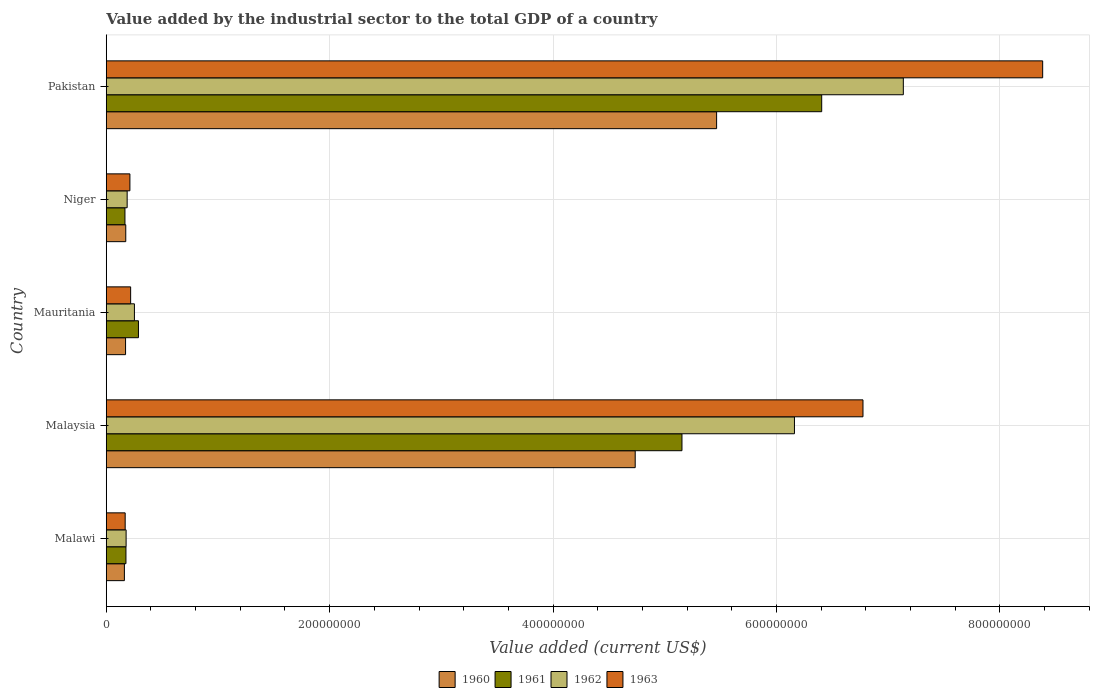Are the number of bars on each tick of the Y-axis equal?
Your answer should be very brief. Yes. How many bars are there on the 3rd tick from the top?
Provide a succinct answer. 4. How many bars are there on the 4th tick from the bottom?
Provide a succinct answer. 4. What is the label of the 3rd group of bars from the top?
Offer a very short reply. Mauritania. What is the value added by the industrial sector to the total GDP in 1961 in Malawi?
Offer a very short reply. 1.76e+07. Across all countries, what is the maximum value added by the industrial sector to the total GDP in 1960?
Ensure brevity in your answer.  5.46e+08. Across all countries, what is the minimum value added by the industrial sector to the total GDP in 1962?
Your response must be concise. 1.78e+07. In which country was the value added by the industrial sector to the total GDP in 1962 minimum?
Ensure brevity in your answer.  Malawi. What is the total value added by the industrial sector to the total GDP in 1963 in the graph?
Offer a terse response. 1.58e+09. What is the difference between the value added by the industrial sector to the total GDP in 1962 in Malaysia and that in Niger?
Offer a very short reply. 5.97e+08. What is the difference between the value added by the industrial sector to the total GDP in 1961 in Malaysia and the value added by the industrial sector to the total GDP in 1960 in Pakistan?
Keep it short and to the point. -3.10e+07. What is the average value added by the industrial sector to the total GDP in 1962 per country?
Keep it short and to the point. 2.78e+08. What is the difference between the value added by the industrial sector to the total GDP in 1961 and value added by the industrial sector to the total GDP in 1962 in Malaysia?
Ensure brevity in your answer.  -1.01e+08. In how many countries, is the value added by the industrial sector to the total GDP in 1963 greater than 40000000 US$?
Keep it short and to the point. 2. What is the ratio of the value added by the industrial sector to the total GDP in 1962 in Malawi to that in Niger?
Your answer should be very brief. 0.95. Is the difference between the value added by the industrial sector to the total GDP in 1961 in Niger and Pakistan greater than the difference between the value added by the industrial sector to the total GDP in 1962 in Niger and Pakistan?
Offer a very short reply. Yes. What is the difference between the highest and the second highest value added by the industrial sector to the total GDP in 1960?
Offer a very short reply. 7.29e+07. What is the difference between the highest and the lowest value added by the industrial sector to the total GDP in 1961?
Offer a terse response. 6.24e+08. Is it the case that in every country, the sum of the value added by the industrial sector to the total GDP in 1961 and value added by the industrial sector to the total GDP in 1962 is greater than the sum of value added by the industrial sector to the total GDP in 1960 and value added by the industrial sector to the total GDP in 1963?
Offer a very short reply. No. What does the 1st bar from the top in Niger represents?
Offer a terse response. 1963. What does the 1st bar from the bottom in Mauritania represents?
Give a very brief answer. 1960. How many countries are there in the graph?
Ensure brevity in your answer.  5. What is the difference between two consecutive major ticks on the X-axis?
Provide a short and direct response. 2.00e+08. Does the graph contain any zero values?
Provide a succinct answer. No. Does the graph contain grids?
Provide a short and direct response. Yes. How are the legend labels stacked?
Give a very brief answer. Horizontal. What is the title of the graph?
Provide a succinct answer. Value added by the industrial sector to the total GDP of a country. What is the label or title of the X-axis?
Provide a succinct answer. Value added (current US$). What is the Value added (current US$) in 1960 in Malawi?
Offer a very short reply. 1.62e+07. What is the Value added (current US$) of 1961 in Malawi?
Ensure brevity in your answer.  1.76e+07. What is the Value added (current US$) of 1962 in Malawi?
Offer a terse response. 1.78e+07. What is the Value added (current US$) of 1963 in Malawi?
Your answer should be very brief. 1.69e+07. What is the Value added (current US$) in 1960 in Malaysia?
Give a very brief answer. 4.74e+08. What is the Value added (current US$) in 1961 in Malaysia?
Make the answer very short. 5.15e+08. What is the Value added (current US$) of 1962 in Malaysia?
Give a very brief answer. 6.16e+08. What is the Value added (current US$) of 1963 in Malaysia?
Your response must be concise. 6.77e+08. What is the Value added (current US$) in 1960 in Mauritania?
Offer a very short reply. 1.73e+07. What is the Value added (current US$) of 1961 in Mauritania?
Offer a very short reply. 2.88e+07. What is the Value added (current US$) of 1962 in Mauritania?
Keep it short and to the point. 2.52e+07. What is the Value added (current US$) of 1963 in Mauritania?
Make the answer very short. 2.18e+07. What is the Value added (current US$) of 1960 in Niger?
Ensure brevity in your answer.  1.75e+07. What is the Value added (current US$) in 1961 in Niger?
Provide a short and direct response. 1.67e+07. What is the Value added (current US$) in 1962 in Niger?
Provide a succinct answer. 1.87e+07. What is the Value added (current US$) of 1963 in Niger?
Offer a very short reply. 2.12e+07. What is the Value added (current US$) of 1960 in Pakistan?
Keep it short and to the point. 5.46e+08. What is the Value added (current US$) of 1961 in Pakistan?
Give a very brief answer. 6.40e+08. What is the Value added (current US$) of 1962 in Pakistan?
Your response must be concise. 7.14e+08. What is the Value added (current US$) in 1963 in Pakistan?
Provide a succinct answer. 8.38e+08. Across all countries, what is the maximum Value added (current US$) in 1960?
Your response must be concise. 5.46e+08. Across all countries, what is the maximum Value added (current US$) of 1961?
Your answer should be compact. 6.40e+08. Across all countries, what is the maximum Value added (current US$) of 1962?
Ensure brevity in your answer.  7.14e+08. Across all countries, what is the maximum Value added (current US$) of 1963?
Your answer should be compact. 8.38e+08. Across all countries, what is the minimum Value added (current US$) of 1960?
Keep it short and to the point. 1.62e+07. Across all countries, what is the minimum Value added (current US$) of 1961?
Your answer should be very brief. 1.67e+07. Across all countries, what is the minimum Value added (current US$) in 1962?
Give a very brief answer. 1.78e+07. Across all countries, what is the minimum Value added (current US$) in 1963?
Provide a succinct answer. 1.69e+07. What is the total Value added (current US$) in 1960 in the graph?
Make the answer very short. 1.07e+09. What is the total Value added (current US$) of 1961 in the graph?
Give a very brief answer. 1.22e+09. What is the total Value added (current US$) in 1962 in the graph?
Provide a succinct answer. 1.39e+09. What is the total Value added (current US$) of 1963 in the graph?
Ensure brevity in your answer.  1.58e+09. What is the difference between the Value added (current US$) of 1960 in Malawi and that in Malaysia?
Your answer should be very brief. -4.57e+08. What is the difference between the Value added (current US$) in 1961 in Malawi and that in Malaysia?
Keep it short and to the point. -4.98e+08. What is the difference between the Value added (current US$) of 1962 in Malawi and that in Malaysia?
Give a very brief answer. -5.98e+08. What is the difference between the Value added (current US$) of 1963 in Malawi and that in Malaysia?
Your answer should be very brief. -6.61e+08. What is the difference between the Value added (current US$) in 1960 in Malawi and that in Mauritania?
Your response must be concise. -1.06e+06. What is the difference between the Value added (current US$) in 1961 in Malawi and that in Mauritania?
Offer a terse response. -1.12e+07. What is the difference between the Value added (current US$) in 1962 in Malawi and that in Mauritania?
Your response must be concise. -7.44e+06. What is the difference between the Value added (current US$) of 1963 in Malawi and that in Mauritania?
Give a very brief answer. -4.90e+06. What is the difference between the Value added (current US$) of 1960 in Malawi and that in Niger?
Ensure brevity in your answer.  -1.23e+06. What is the difference between the Value added (current US$) of 1961 in Malawi and that in Niger?
Ensure brevity in your answer.  8.98e+05. What is the difference between the Value added (current US$) of 1962 in Malawi and that in Niger?
Offer a very short reply. -9.35e+05. What is the difference between the Value added (current US$) in 1963 in Malawi and that in Niger?
Ensure brevity in your answer.  -4.25e+06. What is the difference between the Value added (current US$) of 1960 in Malawi and that in Pakistan?
Ensure brevity in your answer.  -5.30e+08. What is the difference between the Value added (current US$) of 1961 in Malawi and that in Pakistan?
Ensure brevity in your answer.  -6.23e+08. What is the difference between the Value added (current US$) of 1962 in Malawi and that in Pakistan?
Ensure brevity in your answer.  -6.96e+08. What is the difference between the Value added (current US$) of 1963 in Malawi and that in Pakistan?
Offer a terse response. -8.21e+08. What is the difference between the Value added (current US$) of 1960 in Malaysia and that in Mauritania?
Keep it short and to the point. 4.56e+08. What is the difference between the Value added (current US$) of 1961 in Malaysia and that in Mauritania?
Offer a very short reply. 4.87e+08. What is the difference between the Value added (current US$) in 1962 in Malaysia and that in Mauritania?
Give a very brief answer. 5.91e+08. What is the difference between the Value added (current US$) of 1963 in Malaysia and that in Mauritania?
Give a very brief answer. 6.56e+08. What is the difference between the Value added (current US$) of 1960 in Malaysia and that in Niger?
Provide a short and direct response. 4.56e+08. What is the difference between the Value added (current US$) of 1961 in Malaysia and that in Niger?
Ensure brevity in your answer.  4.99e+08. What is the difference between the Value added (current US$) of 1962 in Malaysia and that in Niger?
Provide a succinct answer. 5.97e+08. What is the difference between the Value added (current US$) in 1963 in Malaysia and that in Niger?
Your response must be concise. 6.56e+08. What is the difference between the Value added (current US$) in 1960 in Malaysia and that in Pakistan?
Keep it short and to the point. -7.29e+07. What is the difference between the Value added (current US$) of 1961 in Malaysia and that in Pakistan?
Offer a terse response. -1.25e+08. What is the difference between the Value added (current US$) in 1962 in Malaysia and that in Pakistan?
Offer a terse response. -9.75e+07. What is the difference between the Value added (current US$) of 1963 in Malaysia and that in Pakistan?
Provide a succinct answer. -1.61e+08. What is the difference between the Value added (current US$) in 1960 in Mauritania and that in Niger?
Offer a very short reply. -1.73e+05. What is the difference between the Value added (current US$) in 1961 in Mauritania and that in Niger?
Provide a succinct answer. 1.21e+07. What is the difference between the Value added (current US$) of 1962 in Mauritania and that in Niger?
Your answer should be compact. 6.51e+06. What is the difference between the Value added (current US$) of 1963 in Mauritania and that in Niger?
Your answer should be compact. 6.57e+05. What is the difference between the Value added (current US$) in 1960 in Mauritania and that in Pakistan?
Your response must be concise. -5.29e+08. What is the difference between the Value added (current US$) in 1961 in Mauritania and that in Pakistan?
Make the answer very short. -6.12e+08. What is the difference between the Value added (current US$) in 1962 in Mauritania and that in Pakistan?
Your answer should be very brief. -6.88e+08. What is the difference between the Value added (current US$) of 1963 in Mauritania and that in Pakistan?
Provide a short and direct response. -8.16e+08. What is the difference between the Value added (current US$) in 1960 in Niger and that in Pakistan?
Ensure brevity in your answer.  -5.29e+08. What is the difference between the Value added (current US$) in 1961 in Niger and that in Pakistan?
Provide a succinct answer. -6.24e+08. What is the difference between the Value added (current US$) of 1962 in Niger and that in Pakistan?
Ensure brevity in your answer.  -6.95e+08. What is the difference between the Value added (current US$) in 1963 in Niger and that in Pakistan?
Offer a very short reply. -8.17e+08. What is the difference between the Value added (current US$) of 1960 in Malawi and the Value added (current US$) of 1961 in Malaysia?
Offer a terse response. -4.99e+08. What is the difference between the Value added (current US$) in 1960 in Malawi and the Value added (current US$) in 1962 in Malaysia?
Make the answer very short. -6.00e+08. What is the difference between the Value added (current US$) of 1960 in Malawi and the Value added (current US$) of 1963 in Malaysia?
Keep it short and to the point. -6.61e+08. What is the difference between the Value added (current US$) in 1961 in Malawi and the Value added (current US$) in 1962 in Malaysia?
Provide a succinct answer. -5.98e+08. What is the difference between the Value added (current US$) of 1961 in Malawi and the Value added (current US$) of 1963 in Malaysia?
Keep it short and to the point. -6.60e+08. What is the difference between the Value added (current US$) of 1962 in Malawi and the Value added (current US$) of 1963 in Malaysia?
Give a very brief answer. -6.60e+08. What is the difference between the Value added (current US$) of 1960 in Malawi and the Value added (current US$) of 1961 in Mauritania?
Provide a short and direct response. -1.26e+07. What is the difference between the Value added (current US$) of 1960 in Malawi and the Value added (current US$) of 1962 in Mauritania?
Offer a terse response. -8.98e+06. What is the difference between the Value added (current US$) of 1960 in Malawi and the Value added (current US$) of 1963 in Mauritania?
Make the answer very short. -5.60e+06. What is the difference between the Value added (current US$) in 1961 in Malawi and the Value added (current US$) in 1962 in Mauritania?
Your answer should be very brief. -7.58e+06. What is the difference between the Value added (current US$) in 1961 in Malawi and the Value added (current US$) in 1963 in Mauritania?
Give a very brief answer. -4.20e+06. What is the difference between the Value added (current US$) of 1962 in Malawi and the Value added (current US$) of 1963 in Mauritania?
Keep it short and to the point. -4.06e+06. What is the difference between the Value added (current US$) in 1960 in Malawi and the Value added (current US$) in 1961 in Niger?
Keep it short and to the point. -5.02e+05. What is the difference between the Value added (current US$) in 1960 in Malawi and the Value added (current US$) in 1962 in Niger?
Ensure brevity in your answer.  -2.48e+06. What is the difference between the Value added (current US$) of 1960 in Malawi and the Value added (current US$) of 1963 in Niger?
Your answer should be very brief. -4.95e+06. What is the difference between the Value added (current US$) of 1961 in Malawi and the Value added (current US$) of 1962 in Niger?
Ensure brevity in your answer.  -1.08e+06. What is the difference between the Value added (current US$) in 1961 in Malawi and the Value added (current US$) in 1963 in Niger?
Your answer should be compact. -3.55e+06. What is the difference between the Value added (current US$) of 1962 in Malawi and the Value added (current US$) of 1963 in Niger?
Provide a short and direct response. -3.41e+06. What is the difference between the Value added (current US$) of 1960 in Malawi and the Value added (current US$) of 1961 in Pakistan?
Give a very brief answer. -6.24e+08. What is the difference between the Value added (current US$) of 1960 in Malawi and the Value added (current US$) of 1962 in Pakistan?
Give a very brief answer. -6.97e+08. What is the difference between the Value added (current US$) of 1960 in Malawi and the Value added (current US$) of 1963 in Pakistan?
Provide a short and direct response. -8.22e+08. What is the difference between the Value added (current US$) in 1961 in Malawi and the Value added (current US$) in 1962 in Pakistan?
Provide a short and direct response. -6.96e+08. What is the difference between the Value added (current US$) in 1961 in Malawi and the Value added (current US$) in 1963 in Pakistan?
Make the answer very short. -8.21e+08. What is the difference between the Value added (current US$) of 1962 in Malawi and the Value added (current US$) of 1963 in Pakistan?
Your response must be concise. -8.21e+08. What is the difference between the Value added (current US$) of 1960 in Malaysia and the Value added (current US$) of 1961 in Mauritania?
Your answer should be very brief. 4.45e+08. What is the difference between the Value added (current US$) of 1960 in Malaysia and the Value added (current US$) of 1962 in Mauritania?
Give a very brief answer. 4.48e+08. What is the difference between the Value added (current US$) of 1960 in Malaysia and the Value added (current US$) of 1963 in Mauritania?
Your response must be concise. 4.52e+08. What is the difference between the Value added (current US$) in 1961 in Malaysia and the Value added (current US$) in 1962 in Mauritania?
Give a very brief answer. 4.90e+08. What is the difference between the Value added (current US$) in 1961 in Malaysia and the Value added (current US$) in 1963 in Mauritania?
Your response must be concise. 4.94e+08. What is the difference between the Value added (current US$) in 1962 in Malaysia and the Value added (current US$) in 1963 in Mauritania?
Make the answer very short. 5.94e+08. What is the difference between the Value added (current US$) in 1960 in Malaysia and the Value added (current US$) in 1961 in Niger?
Give a very brief answer. 4.57e+08. What is the difference between the Value added (current US$) of 1960 in Malaysia and the Value added (current US$) of 1962 in Niger?
Offer a terse response. 4.55e+08. What is the difference between the Value added (current US$) of 1960 in Malaysia and the Value added (current US$) of 1963 in Niger?
Your answer should be very brief. 4.52e+08. What is the difference between the Value added (current US$) in 1961 in Malaysia and the Value added (current US$) in 1962 in Niger?
Make the answer very short. 4.97e+08. What is the difference between the Value added (current US$) of 1961 in Malaysia and the Value added (current US$) of 1963 in Niger?
Keep it short and to the point. 4.94e+08. What is the difference between the Value added (current US$) of 1962 in Malaysia and the Value added (current US$) of 1963 in Niger?
Provide a short and direct response. 5.95e+08. What is the difference between the Value added (current US$) in 1960 in Malaysia and the Value added (current US$) in 1961 in Pakistan?
Your response must be concise. -1.67e+08. What is the difference between the Value added (current US$) of 1960 in Malaysia and the Value added (current US$) of 1962 in Pakistan?
Keep it short and to the point. -2.40e+08. What is the difference between the Value added (current US$) of 1960 in Malaysia and the Value added (current US$) of 1963 in Pakistan?
Your answer should be very brief. -3.65e+08. What is the difference between the Value added (current US$) of 1961 in Malaysia and the Value added (current US$) of 1962 in Pakistan?
Provide a succinct answer. -1.98e+08. What is the difference between the Value added (current US$) of 1961 in Malaysia and the Value added (current US$) of 1963 in Pakistan?
Make the answer very short. -3.23e+08. What is the difference between the Value added (current US$) of 1962 in Malaysia and the Value added (current US$) of 1963 in Pakistan?
Provide a succinct answer. -2.22e+08. What is the difference between the Value added (current US$) of 1960 in Mauritania and the Value added (current US$) of 1961 in Niger?
Your answer should be compact. 5.53e+05. What is the difference between the Value added (current US$) in 1960 in Mauritania and the Value added (current US$) in 1962 in Niger?
Provide a succinct answer. -1.42e+06. What is the difference between the Value added (current US$) of 1960 in Mauritania and the Value added (current US$) of 1963 in Niger?
Your answer should be very brief. -3.89e+06. What is the difference between the Value added (current US$) of 1961 in Mauritania and the Value added (current US$) of 1962 in Niger?
Provide a succinct answer. 1.01e+07. What is the difference between the Value added (current US$) in 1961 in Mauritania and the Value added (current US$) in 1963 in Niger?
Your answer should be compact. 7.64e+06. What is the difference between the Value added (current US$) in 1962 in Mauritania and the Value added (current US$) in 1963 in Niger?
Your response must be concise. 4.04e+06. What is the difference between the Value added (current US$) of 1960 in Mauritania and the Value added (current US$) of 1961 in Pakistan?
Provide a succinct answer. -6.23e+08. What is the difference between the Value added (current US$) in 1960 in Mauritania and the Value added (current US$) in 1962 in Pakistan?
Offer a terse response. -6.96e+08. What is the difference between the Value added (current US$) of 1960 in Mauritania and the Value added (current US$) of 1963 in Pakistan?
Make the answer very short. -8.21e+08. What is the difference between the Value added (current US$) of 1961 in Mauritania and the Value added (current US$) of 1962 in Pakistan?
Your response must be concise. -6.85e+08. What is the difference between the Value added (current US$) of 1961 in Mauritania and the Value added (current US$) of 1963 in Pakistan?
Provide a succinct answer. -8.09e+08. What is the difference between the Value added (current US$) in 1962 in Mauritania and the Value added (current US$) in 1963 in Pakistan?
Your response must be concise. -8.13e+08. What is the difference between the Value added (current US$) in 1960 in Niger and the Value added (current US$) in 1961 in Pakistan?
Provide a succinct answer. -6.23e+08. What is the difference between the Value added (current US$) of 1960 in Niger and the Value added (current US$) of 1962 in Pakistan?
Your response must be concise. -6.96e+08. What is the difference between the Value added (current US$) of 1960 in Niger and the Value added (current US$) of 1963 in Pakistan?
Provide a succinct answer. -8.21e+08. What is the difference between the Value added (current US$) in 1961 in Niger and the Value added (current US$) in 1962 in Pakistan?
Give a very brief answer. -6.97e+08. What is the difference between the Value added (current US$) in 1961 in Niger and the Value added (current US$) in 1963 in Pakistan?
Your answer should be compact. -8.22e+08. What is the difference between the Value added (current US$) of 1962 in Niger and the Value added (current US$) of 1963 in Pakistan?
Offer a very short reply. -8.20e+08. What is the average Value added (current US$) in 1960 per country?
Offer a very short reply. 2.14e+08. What is the average Value added (current US$) in 1961 per country?
Your answer should be compact. 2.44e+08. What is the average Value added (current US$) of 1962 per country?
Your response must be concise. 2.78e+08. What is the average Value added (current US$) in 1963 per country?
Keep it short and to the point. 3.15e+08. What is the difference between the Value added (current US$) of 1960 and Value added (current US$) of 1961 in Malawi?
Your response must be concise. -1.40e+06. What is the difference between the Value added (current US$) of 1960 and Value added (current US$) of 1962 in Malawi?
Provide a short and direct response. -1.54e+06. What is the difference between the Value added (current US$) of 1960 and Value added (current US$) of 1963 in Malawi?
Provide a succinct answer. -7.00e+05. What is the difference between the Value added (current US$) of 1961 and Value added (current US$) of 1962 in Malawi?
Your response must be concise. -1.40e+05. What is the difference between the Value added (current US$) in 1961 and Value added (current US$) in 1963 in Malawi?
Your answer should be very brief. 7.00e+05. What is the difference between the Value added (current US$) in 1962 and Value added (current US$) in 1963 in Malawi?
Your response must be concise. 8.40e+05. What is the difference between the Value added (current US$) of 1960 and Value added (current US$) of 1961 in Malaysia?
Give a very brief answer. -4.19e+07. What is the difference between the Value added (current US$) of 1960 and Value added (current US$) of 1962 in Malaysia?
Give a very brief answer. -1.43e+08. What is the difference between the Value added (current US$) in 1960 and Value added (current US$) in 1963 in Malaysia?
Keep it short and to the point. -2.04e+08. What is the difference between the Value added (current US$) of 1961 and Value added (current US$) of 1962 in Malaysia?
Ensure brevity in your answer.  -1.01e+08. What is the difference between the Value added (current US$) in 1961 and Value added (current US$) in 1963 in Malaysia?
Keep it short and to the point. -1.62e+08. What is the difference between the Value added (current US$) of 1962 and Value added (current US$) of 1963 in Malaysia?
Offer a terse response. -6.14e+07. What is the difference between the Value added (current US$) of 1960 and Value added (current US$) of 1961 in Mauritania?
Provide a succinct answer. -1.15e+07. What is the difference between the Value added (current US$) in 1960 and Value added (current US$) in 1962 in Mauritania?
Provide a succinct answer. -7.93e+06. What is the difference between the Value added (current US$) of 1960 and Value added (current US$) of 1963 in Mauritania?
Provide a succinct answer. -4.55e+06. What is the difference between the Value added (current US$) in 1961 and Value added (current US$) in 1962 in Mauritania?
Make the answer very short. 3.60e+06. What is the difference between the Value added (current US$) of 1961 and Value added (current US$) of 1963 in Mauritania?
Your response must be concise. 6.98e+06. What is the difference between the Value added (current US$) of 1962 and Value added (current US$) of 1963 in Mauritania?
Your answer should be compact. 3.38e+06. What is the difference between the Value added (current US$) in 1960 and Value added (current US$) in 1961 in Niger?
Offer a terse response. 7.26e+05. What is the difference between the Value added (current US$) of 1960 and Value added (current US$) of 1962 in Niger?
Offer a very short reply. -1.25e+06. What is the difference between the Value added (current US$) in 1960 and Value added (current US$) in 1963 in Niger?
Your response must be concise. -3.72e+06. What is the difference between the Value added (current US$) of 1961 and Value added (current US$) of 1962 in Niger?
Your answer should be very brief. -1.97e+06. What is the difference between the Value added (current US$) of 1961 and Value added (current US$) of 1963 in Niger?
Keep it short and to the point. -4.44e+06. What is the difference between the Value added (current US$) of 1962 and Value added (current US$) of 1963 in Niger?
Offer a terse response. -2.47e+06. What is the difference between the Value added (current US$) in 1960 and Value added (current US$) in 1961 in Pakistan?
Give a very brief answer. -9.41e+07. What is the difference between the Value added (current US$) of 1960 and Value added (current US$) of 1962 in Pakistan?
Make the answer very short. -1.67e+08. What is the difference between the Value added (current US$) in 1960 and Value added (current US$) in 1963 in Pakistan?
Ensure brevity in your answer.  -2.92e+08. What is the difference between the Value added (current US$) in 1961 and Value added (current US$) in 1962 in Pakistan?
Your answer should be compact. -7.31e+07. What is the difference between the Value added (current US$) in 1961 and Value added (current US$) in 1963 in Pakistan?
Ensure brevity in your answer.  -1.98e+08. What is the difference between the Value added (current US$) in 1962 and Value added (current US$) in 1963 in Pakistan?
Your answer should be very brief. -1.25e+08. What is the ratio of the Value added (current US$) in 1960 in Malawi to that in Malaysia?
Give a very brief answer. 0.03. What is the ratio of the Value added (current US$) in 1961 in Malawi to that in Malaysia?
Your answer should be very brief. 0.03. What is the ratio of the Value added (current US$) in 1962 in Malawi to that in Malaysia?
Make the answer very short. 0.03. What is the ratio of the Value added (current US$) in 1963 in Malawi to that in Malaysia?
Give a very brief answer. 0.03. What is the ratio of the Value added (current US$) in 1960 in Malawi to that in Mauritania?
Keep it short and to the point. 0.94. What is the ratio of the Value added (current US$) of 1961 in Malawi to that in Mauritania?
Provide a succinct answer. 0.61. What is the ratio of the Value added (current US$) in 1962 in Malawi to that in Mauritania?
Offer a very short reply. 0.7. What is the ratio of the Value added (current US$) of 1963 in Malawi to that in Mauritania?
Your answer should be very brief. 0.78. What is the ratio of the Value added (current US$) of 1960 in Malawi to that in Niger?
Your answer should be very brief. 0.93. What is the ratio of the Value added (current US$) of 1961 in Malawi to that in Niger?
Make the answer very short. 1.05. What is the ratio of the Value added (current US$) of 1962 in Malawi to that in Niger?
Your answer should be very brief. 0.95. What is the ratio of the Value added (current US$) of 1963 in Malawi to that in Niger?
Your answer should be compact. 0.8. What is the ratio of the Value added (current US$) of 1960 in Malawi to that in Pakistan?
Provide a succinct answer. 0.03. What is the ratio of the Value added (current US$) of 1961 in Malawi to that in Pakistan?
Offer a terse response. 0.03. What is the ratio of the Value added (current US$) of 1962 in Malawi to that in Pakistan?
Provide a succinct answer. 0.02. What is the ratio of the Value added (current US$) in 1963 in Malawi to that in Pakistan?
Provide a short and direct response. 0.02. What is the ratio of the Value added (current US$) of 1960 in Malaysia to that in Mauritania?
Your answer should be compact. 27.38. What is the ratio of the Value added (current US$) in 1961 in Malaysia to that in Mauritania?
Your answer should be very brief. 17.88. What is the ratio of the Value added (current US$) in 1962 in Malaysia to that in Mauritania?
Give a very brief answer. 24.43. What is the ratio of the Value added (current US$) in 1963 in Malaysia to that in Mauritania?
Keep it short and to the point. 31.01. What is the ratio of the Value added (current US$) of 1960 in Malaysia to that in Niger?
Your answer should be very brief. 27.11. What is the ratio of the Value added (current US$) in 1961 in Malaysia to that in Niger?
Keep it short and to the point. 30.78. What is the ratio of the Value added (current US$) in 1962 in Malaysia to that in Niger?
Give a very brief answer. 32.92. What is the ratio of the Value added (current US$) in 1963 in Malaysia to that in Niger?
Ensure brevity in your answer.  31.98. What is the ratio of the Value added (current US$) of 1960 in Malaysia to that in Pakistan?
Keep it short and to the point. 0.87. What is the ratio of the Value added (current US$) of 1961 in Malaysia to that in Pakistan?
Your answer should be compact. 0.8. What is the ratio of the Value added (current US$) of 1962 in Malaysia to that in Pakistan?
Make the answer very short. 0.86. What is the ratio of the Value added (current US$) of 1963 in Malaysia to that in Pakistan?
Your response must be concise. 0.81. What is the ratio of the Value added (current US$) of 1961 in Mauritania to that in Niger?
Provide a short and direct response. 1.72. What is the ratio of the Value added (current US$) of 1962 in Mauritania to that in Niger?
Offer a terse response. 1.35. What is the ratio of the Value added (current US$) in 1963 in Mauritania to that in Niger?
Ensure brevity in your answer.  1.03. What is the ratio of the Value added (current US$) of 1960 in Mauritania to that in Pakistan?
Keep it short and to the point. 0.03. What is the ratio of the Value added (current US$) in 1961 in Mauritania to that in Pakistan?
Your answer should be very brief. 0.04. What is the ratio of the Value added (current US$) in 1962 in Mauritania to that in Pakistan?
Your response must be concise. 0.04. What is the ratio of the Value added (current US$) of 1963 in Mauritania to that in Pakistan?
Give a very brief answer. 0.03. What is the ratio of the Value added (current US$) of 1960 in Niger to that in Pakistan?
Provide a short and direct response. 0.03. What is the ratio of the Value added (current US$) of 1961 in Niger to that in Pakistan?
Give a very brief answer. 0.03. What is the ratio of the Value added (current US$) in 1962 in Niger to that in Pakistan?
Give a very brief answer. 0.03. What is the ratio of the Value added (current US$) of 1963 in Niger to that in Pakistan?
Provide a succinct answer. 0.03. What is the difference between the highest and the second highest Value added (current US$) in 1960?
Offer a very short reply. 7.29e+07. What is the difference between the highest and the second highest Value added (current US$) in 1961?
Your answer should be compact. 1.25e+08. What is the difference between the highest and the second highest Value added (current US$) of 1962?
Your answer should be compact. 9.75e+07. What is the difference between the highest and the second highest Value added (current US$) of 1963?
Give a very brief answer. 1.61e+08. What is the difference between the highest and the lowest Value added (current US$) of 1960?
Keep it short and to the point. 5.30e+08. What is the difference between the highest and the lowest Value added (current US$) of 1961?
Your answer should be very brief. 6.24e+08. What is the difference between the highest and the lowest Value added (current US$) of 1962?
Provide a succinct answer. 6.96e+08. What is the difference between the highest and the lowest Value added (current US$) in 1963?
Make the answer very short. 8.21e+08. 